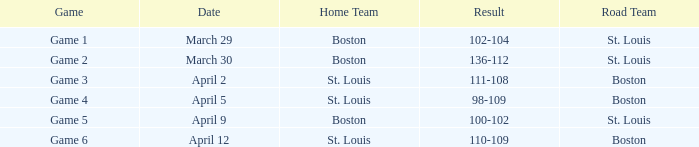What Game had a Result of 136-112? Game 2. 